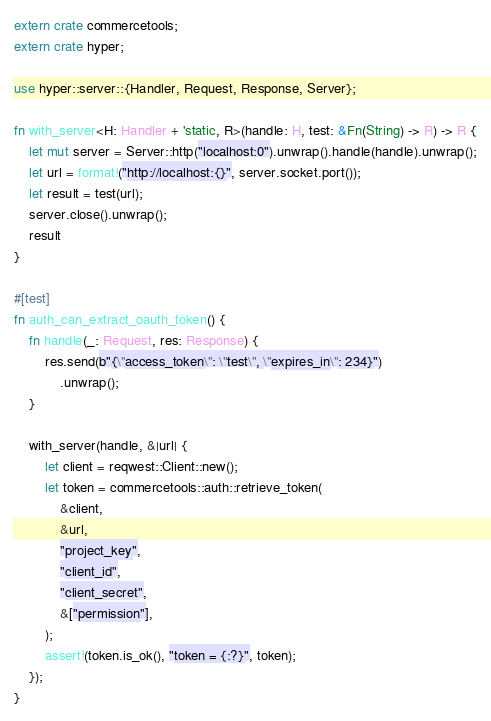<code> <loc_0><loc_0><loc_500><loc_500><_Rust_>extern crate commercetools;
extern crate hyper;

use hyper::server::{Handler, Request, Response, Server};

fn with_server<H: Handler + 'static, R>(handle: H, test: &Fn(String) -> R) -> R {
    let mut server = Server::http("localhost:0").unwrap().handle(handle).unwrap();
    let url = format!("http://localhost:{}", server.socket.port());
    let result = test(url);
    server.close().unwrap();
    result
}

#[test]
fn auth_can_extract_oauth_token() {
    fn handle(_: Request, res: Response) {
        res.send(b"{\"access_token\": \"test\", \"expires_in\": 234}")
            .unwrap();
    }

    with_server(handle, &|url| {
        let client = reqwest::Client::new();
        let token = commercetools::auth::retrieve_token(
            &client,
            &url,
            "project_key",
            "client_id",
            "client_secret",
            &["permission"],
        );
        assert!(token.is_ok(), "token = {:?}", token);
    });
}
</code> 